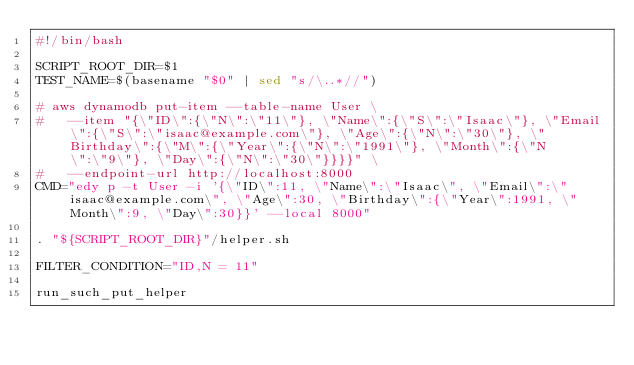Convert code to text. <code><loc_0><loc_0><loc_500><loc_500><_Bash_>#!/bin/bash

SCRIPT_ROOT_DIR=$1
TEST_NAME=$(basename "$0" | sed "s/\..*//")

# aws dynamodb put-item --table-name User \
#   --item "{\"ID\":{\"N\":\"11\"}, \"Name\":{\"S\":\"Isaac\"}, \"Email\":{\"S\":\"isaac@example.com\"}, \"Age\":{\"N\":\"30\"}, \"Birthday\":{\"M\":{\"Year\":{\"N\":\"1991\"}, \"Month\":{\"N\":\"9\"}, \"Day\":{\"N\":\"30\"}}}}" \
#   --endpoint-url http://localhost:8000
CMD="edy p -t User -i '{\"ID\":11, \"Name\":\"Isaac\", \"Email\":\"isaac@example.com\", \"Age\":30, \"Birthday\":{\"Year\":1991, \"Month\":9, \"Day\":30}}' --local 8000"

. "${SCRIPT_ROOT_DIR}"/helper.sh

FILTER_CONDITION="ID,N = 11"

run_such_put_helper
</code> 